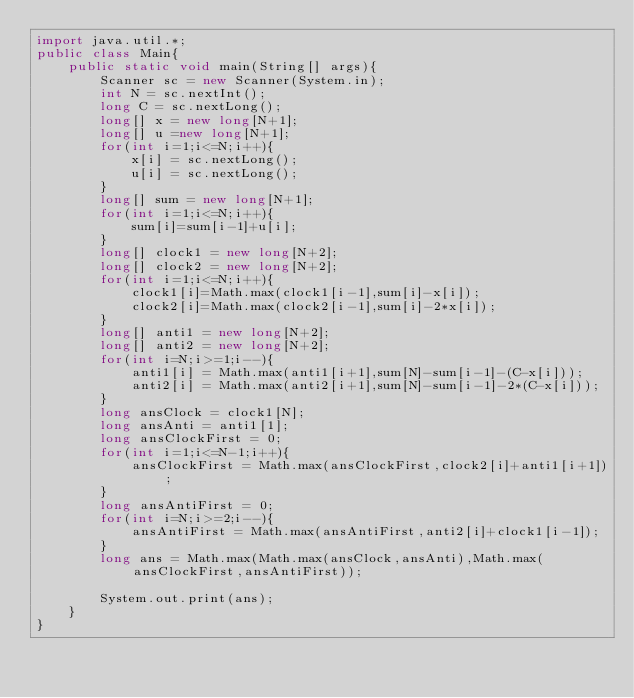Convert code to text. <code><loc_0><loc_0><loc_500><loc_500><_Java_>import java.util.*;
public class Main{
    public static void main(String[] args){
        Scanner sc = new Scanner(System.in);
        int N = sc.nextInt();
        long C = sc.nextLong();
        long[] x = new long[N+1];
        long[] u =new long[N+1];
        for(int i=1;i<=N;i++){
            x[i] = sc.nextLong();
            u[i] = sc.nextLong();
        }
        long[] sum = new long[N+1];
        for(int i=1;i<=N;i++){
            sum[i]=sum[i-1]+u[i];
        }
        long[] clock1 = new long[N+2];
        long[] clock2 = new long[N+2];
        for(int i=1;i<=N;i++){
            clock1[i]=Math.max(clock1[i-1],sum[i]-x[i]);
            clock2[i]=Math.max(clock2[i-1],sum[i]-2*x[i]);
        }
        long[] anti1 = new long[N+2];
        long[] anti2 = new long[N+2];
        for(int i=N;i>=1;i--){
            anti1[i] = Math.max(anti1[i+1],sum[N]-sum[i-1]-(C-x[i]));
            anti2[i] = Math.max(anti2[i+1],sum[N]-sum[i-1]-2*(C-x[i]));
        }
        long ansClock = clock1[N];
        long ansAnti = anti1[1];
        long ansClockFirst = 0;
        for(int i=1;i<=N-1;i++){
            ansClockFirst = Math.max(ansClockFirst,clock2[i]+anti1[i+1]);
        }
        long ansAntiFirst = 0;
        for(int i=N;i>=2;i--){
            ansAntiFirst = Math.max(ansAntiFirst,anti2[i]+clock1[i-1]);
        }
        long ans = Math.max(Math.max(ansClock,ansAnti),Math.max(ansClockFirst,ansAntiFirst));

        System.out.print(ans);
    }
}</code> 